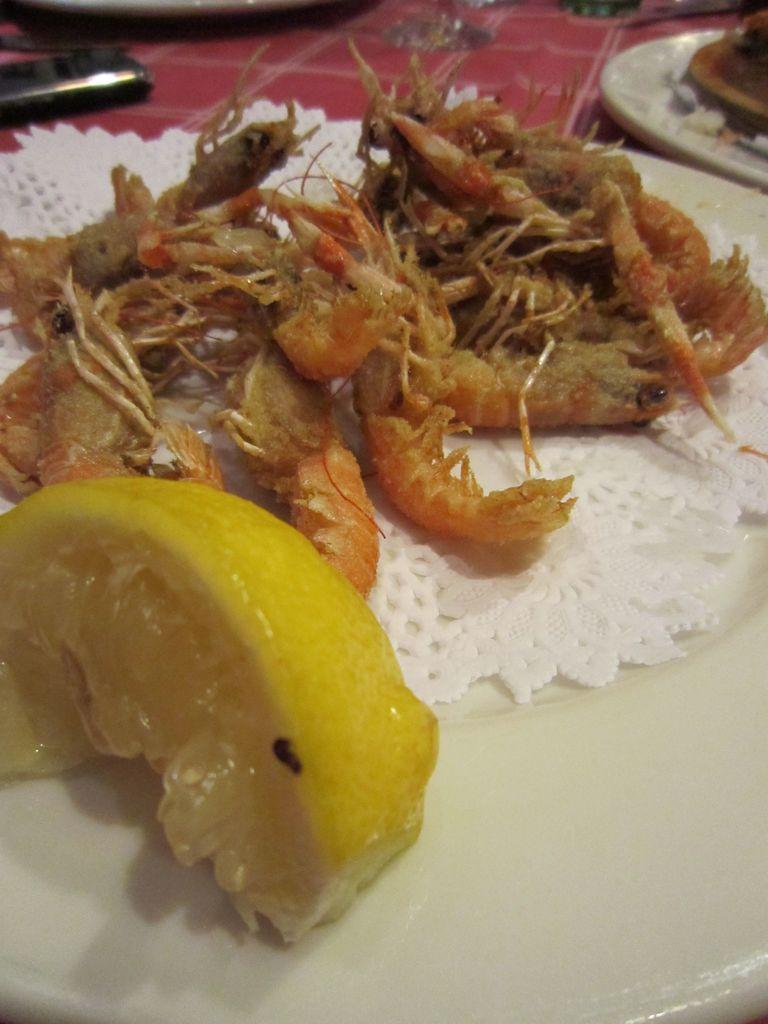In one or two sentences, can you explain what this image depicts? In this picture we can see some eatable item placed in a plate, side we can see one more plate, which are placed on red cloth. 